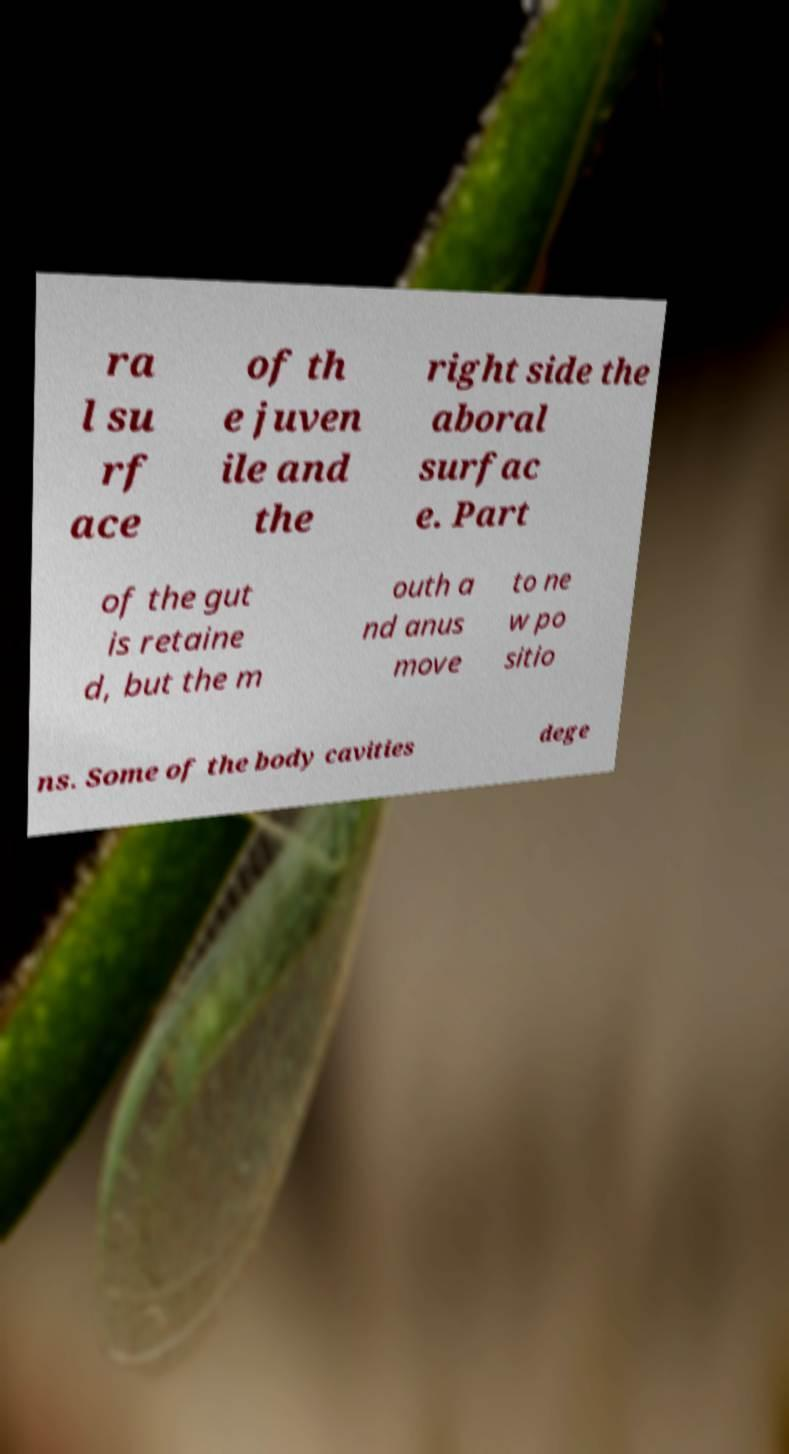Please read and relay the text visible in this image. What does it say? ra l su rf ace of th e juven ile and the right side the aboral surfac e. Part of the gut is retaine d, but the m outh a nd anus move to ne w po sitio ns. Some of the body cavities dege 